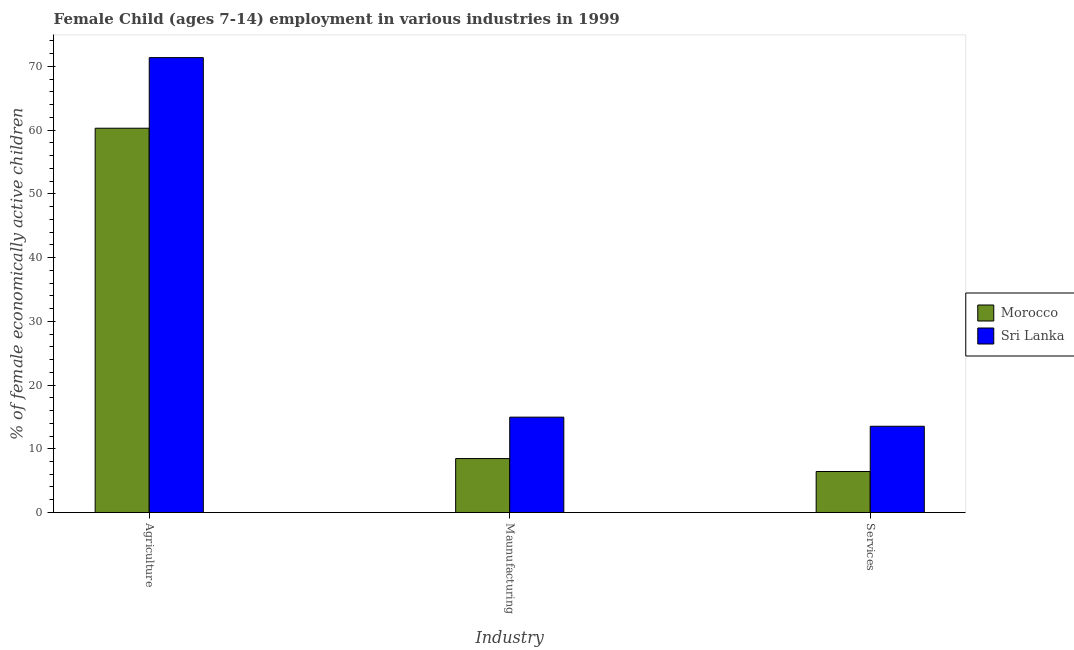How many groups of bars are there?
Provide a short and direct response. 3. How many bars are there on the 1st tick from the left?
Give a very brief answer. 2. How many bars are there on the 2nd tick from the right?
Offer a very short reply. 2. What is the label of the 3rd group of bars from the left?
Your response must be concise. Services. What is the percentage of economically active children in agriculture in Morocco?
Your response must be concise. 60.3. Across all countries, what is the maximum percentage of economically active children in manufacturing?
Make the answer very short. 14.96. Across all countries, what is the minimum percentage of economically active children in manufacturing?
Provide a short and direct response. 8.46. In which country was the percentage of economically active children in manufacturing maximum?
Offer a very short reply. Sri Lanka. In which country was the percentage of economically active children in manufacturing minimum?
Your answer should be very brief. Morocco. What is the total percentage of economically active children in services in the graph?
Make the answer very short. 19.96. What is the difference between the percentage of economically active children in manufacturing in Sri Lanka and that in Morocco?
Make the answer very short. 6.5. What is the difference between the percentage of economically active children in services in Sri Lanka and the percentage of economically active children in agriculture in Morocco?
Your response must be concise. -46.77. What is the average percentage of economically active children in services per country?
Your answer should be very brief. 9.98. What is the difference between the percentage of economically active children in manufacturing and percentage of economically active children in services in Sri Lanka?
Make the answer very short. 1.43. In how many countries, is the percentage of economically active children in agriculture greater than 58 %?
Provide a succinct answer. 2. What is the ratio of the percentage of economically active children in services in Morocco to that in Sri Lanka?
Provide a short and direct response. 0.48. Is the percentage of economically active children in manufacturing in Sri Lanka less than that in Morocco?
Make the answer very short. No. What is the difference between the highest and the second highest percentage of economically active children in agriculture?
Provide a short and direct response. 11.08. What is the difference between the highest and the lowest percentage of economically active children in agriculture?
Offer a very short reply. 11.08. Is the sum of the percentage of economically active children in services in Sri Lanka and Morocco greater than the maximum percentage of economically active children in agriculture across all countries?
Provide a succinct answer. No. What does the 1st bar from the left in Maunufacturing represents?
Provide a succinct answer. Morocco. What does the 1st bar from the right in Agriculture represents?
Offer a very short reply. Sri Lanka. Is it the case that in every country, the sum of the percentage of economically active children in agriculture and percentage of economically active children in manufacturing is greater than the percentage of economically active children in services?
Keep it short and to the point. Yes. How many bars are there?
Make the answer very short. 6. Are all the bars in the graph horizontal?
Your answer should be very brief. No. How many countries are there in the graph?
Provide a short and direct response. 2. Are the values on the major ticks of Y-axis written in scientific E-notation?
Your answer should be very brief. No. Does the graph contain any zero values?
Offer a very short reply. No. How are the legend labels stacked?
Offer a very short reply. Vertical. What is the title of the graph?
Your response must be concise. Female Child (ages 7-14) employment in various industries in 1999. Does "Israel" appear as one of the legend labels in the graph?
Offer a very short reply. No. What is the label or title of the X-axis?
Make the answer very short. Industry. What is the label or title of the Y-axis?
Give a very brief answer. % of female economically active children. What is the % of female economically active children of Morocco in Agriculture?
Your answer should be compact. 60.3. What is the % of female economically active children of Sri Lanka in Agriculture?
Ensure brevity in your answer.  71.38. What is the % of female economically active children in Morocco in Maunufacturing?
Offer a very short reply. 8.46. What is the % of female economically active children of Sri Lanka in Maunufacturing?
Keep it short and to the point. 14.96. What is the % of female economically active children of Morocco in Services?
Give a very brief answer. 6.43. What is the % of female economically active children in Sri Lanka in Services?
Provide a short and direct response. 13.53. Across all Industry, what is the maximum % of female economically active children in Morocco?
Offer a terse response. 60.3. Across all Industry, what is the maximum % of female economically active children in Sri Lanka?
Give a very brief answer. 71.38. Across all Industry, what is the minimum % of female economically active children in Morocco?
Your answer should be compact. 6.43. Across all Industry, what is the minimum % of female economically active children of Sri Lanka?
Offer a terse response. 13.53. What is the total % of female economically active children of Morocco in the graph?
Provide a succinct answer. 75.19. What is the total % of female economically active children in Sri Lanka in the graph?
Provide a succinct answer. 99.87. What is the difference between the % of female economically active children in Morocco in Agriculture and that in Maunufacturing?
Keep it short and to the point. 51.84. What is the difference between the % of female economically active children of Sri Lanka in Agriculture and that in Maunufacturing?
Provide a short and direct response. 56.42. What is the difference between the % of female economically active children of Morocco in Agriculture and that in Services?
Your response must be concise. 53.87. What is the difference between the % of female economically active children in Sri Lanka in Agriculture and that in Services?
Keep it short and to the point. 57.85. What is the difference between the % of female economically active children of Morocco in Maunufacturing and that in Services?
Offer a terse response. 2.03. What is the difference between the % of female economically active children in Sri Lanka in Maunufacturing and that in Services?
Your answer should be compact. 1.43. What is the difference between the % of female economically active children in Morocco in Agriculture and the % of female economically active children in Sri Lanka in Maunufacturing?
Provide a short and direct response. 45.34. What is the difference between the % of female economically active children of Morocco in Agriculture and the % of female economically active children of Sri Lanka in Services?
Offer a very short reply. 46.77. What is the difference between the % of female economically active children in Morocco in Maunufacturing and the % of female economically active children in Sri Lanka in Services?
Offer a terse response. -5.07. What is the average % of female economically active children of Morocco per Industry?
Offer a very short reply. 25.06. What is the average % of female economically active children in Sri Lanka per Industry?
Your answer should be very brief. 33.29. What is the difference between the % of female economically active children in Morocco and % of female economically active children in Sri Lanka in Agriculture?
Give a very brief answer. -11.08. What is the difference between the % of female economically active children in Morocco and % of female economically active children in Sri Lanka in Services?
Give a very brief answer. -7.1. What is the ratio of the % of female economically active children in Morocco in Agriculture to that in Maunufacturing?
Provide a succinct answer. 7.13. What is the ratio of the % of female economically active children of Sri Lanka in Agriculture to that in Maunufacturing?
Your response must be concise. 4.77. What is the ratio of the % of female economically active children of Morocco in Agriculture to that in Services?
Provide a succinct answer. 9.38. What is the ratio of the % of female economically active children of Sri Lanka in Agriculture to that in Services?
Your answer should be compact. 5.28. What is the ratio of the % of female economically active children in Morocco in Maunufacturing to that in Services?
Your response must be concise. 1.32. What is the ratio of the % of female economically active children of Sri Lanka in Maunufacturing to that in Services?
Your answer should be very brief. 1.11. What is the difference between the highest and the second highest % of female economically active children in Morocco?
Ensure brevity in your answer.  51.84. What is the difference between the highest and the second highest % of female economically active children of Sri Lanka?
Offer a terse response. 56.42. What is the difference between the highest and the lowest % of female economically active children of Morocco?
Your answer should be very brief. 53.87. What is the difference between the highest and the lowest % of female economically active children of Sri Lanka?
Make the answer very short. 57.85. 